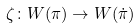Convert formula to latex. <formula><loc_0><loc_0><loc_500><loc_500>\zeta \colon W ( \pi ) \rightarrow W ( \dot { \pi } )</formula> 